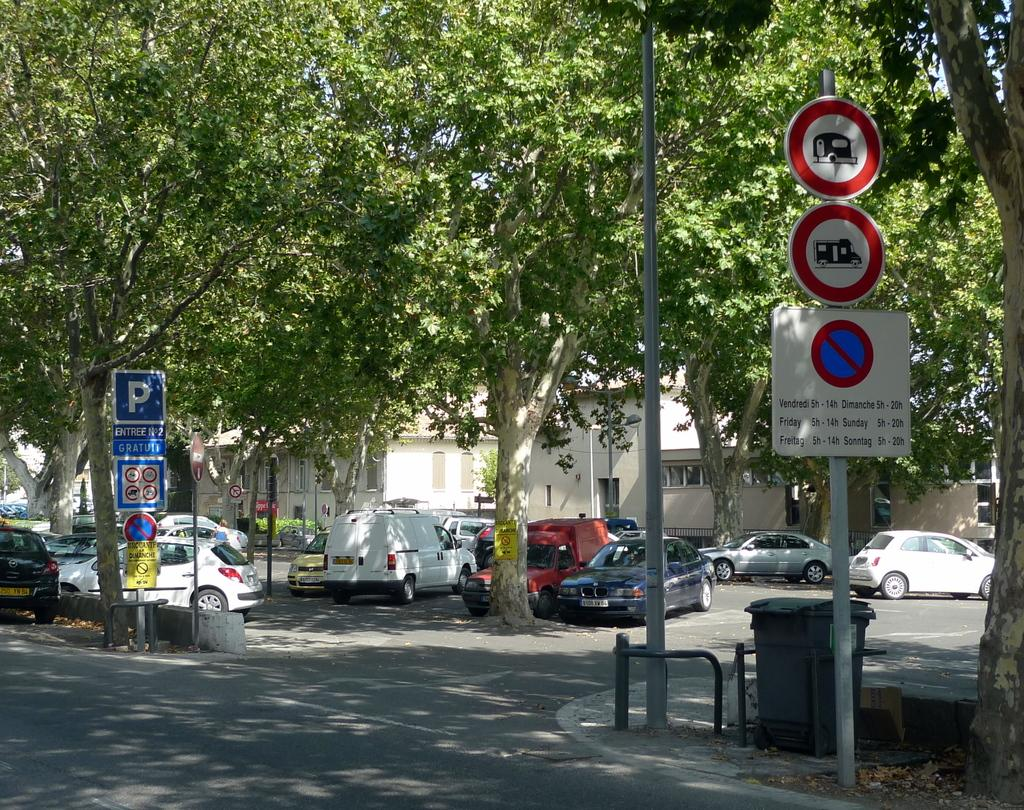<image>
Summarize the visual content of the image. many signs with one that has Sunday hours on it 